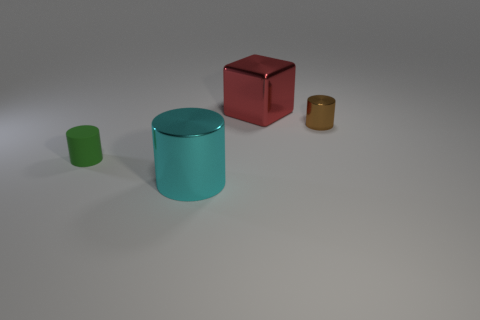Is there anything else that has the same material as the green object?
Offer a very short reply. No. What material is the small object that is on the left side of the large object behind the tiny thing to the left of the tiny metal cylinder?
Your answer should be compact. Rubber. What is the color of the other tiny thing that is the same shape as the green thing?
Give a very brief answer. Brown. Is there anything else that is the same shape as the big red object?
Your answer should be very brief. No. There is a thing that is in front of the small green rubber thing; does it have the same shape as the thing that is on the right side of the red thing?
Your response must be concise. Yes. Do the red metallic block and the shiny cylinder that is right of the large red shiny thing have the same size?
Give a very brief answer. No. Is the number of tiny green metal things greater than the number of large red metal objects?
Give a very brief answer. No. Is the material of the big object that is behind the tiny brown metallic cylinder the same as the small cylinder that is left of the large cyan cylinder?
Offer a very short reply. No. What is the large red thing made of?
Your response must be concise. Metal. Is the number of tiny brown objects that are in front of the small green thing greater than the number of big red metal objects?
Ensure brevity in your answer.  No. 